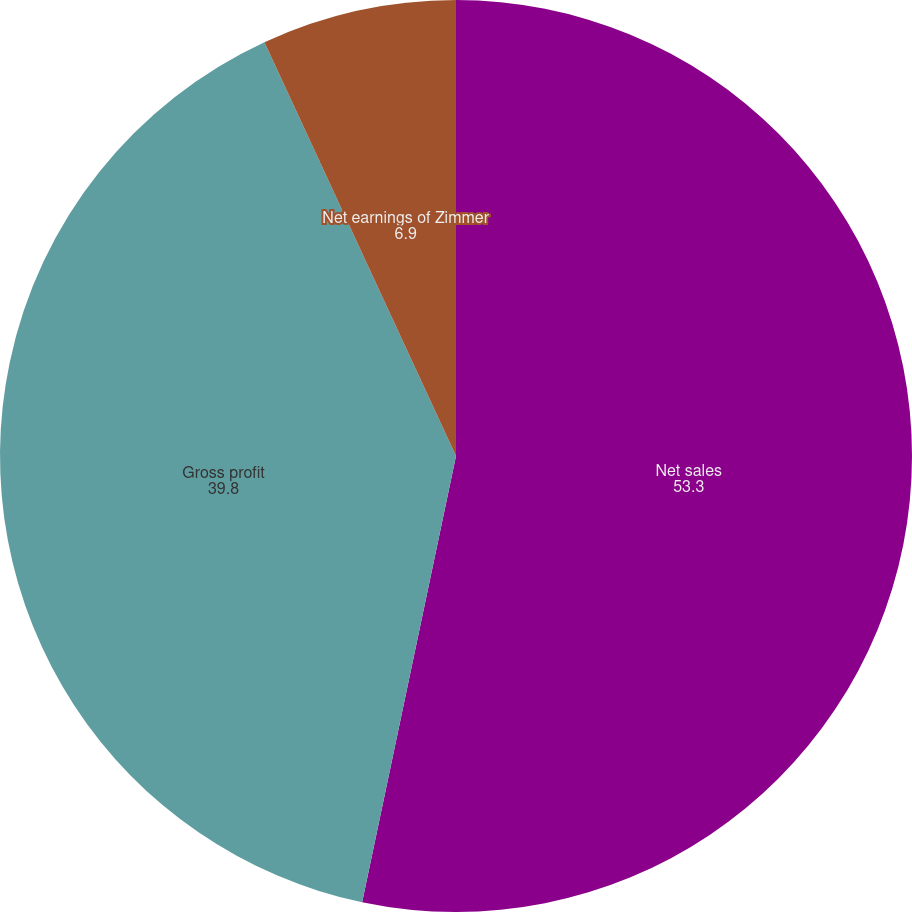Convert chart to OTSL. <chart><loc_0><loc_0><loc_500><loc_500><pie_chart><fcel>Net sales<fcel>Gross profit<fcel>Net earnings of Zimmer<nl><fcel>53.3%<fcel>39.8%<fcel>6.9%<nl></chart> 